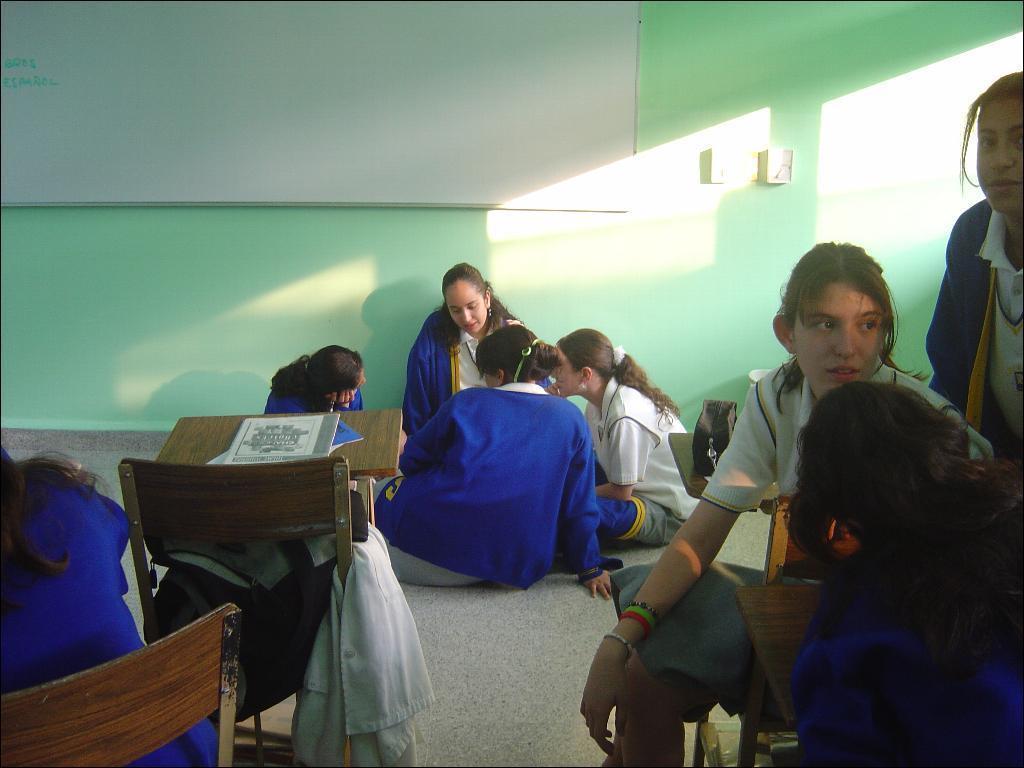Can you describe this image briefly? In this image, we can see a few people. We can see the ground. We can see a few chairs and tables with some objects. We can also see a cloth. We can see a white board. We can see the wall with some objects. 